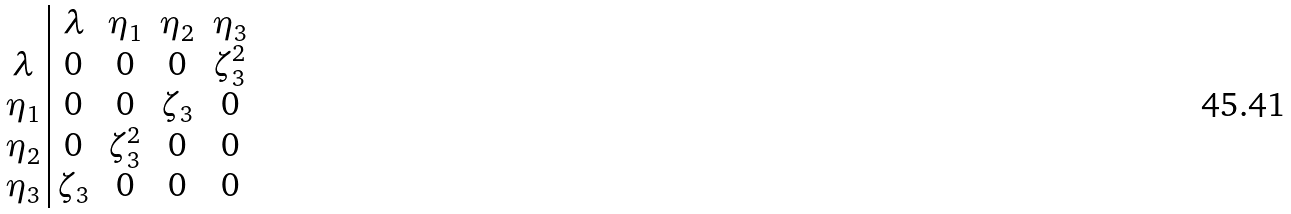<formula> <loc_0><loc_0><loc_500><loc_500>\begin{array} { c | c c c c } & \lambda & \eta _ { 1 } & \eta _ { 2 } & \eta _ { 3 } \\ \lambda & 0 & 0 & 0 & \zeta _ { 3 } ^ { 2 } \\ \eta _ { 1 } & 0 & 0 & \zeta _ { 3 } & 0 \\ \eta _ { 2 } & 0 & \zeta _ { 3 } ^ { 2 } & 0 & 0 \\ \eta _ { 3 } & \zeta _ { 3 } & 0 & 0 & 0 \end{array}</formula> 